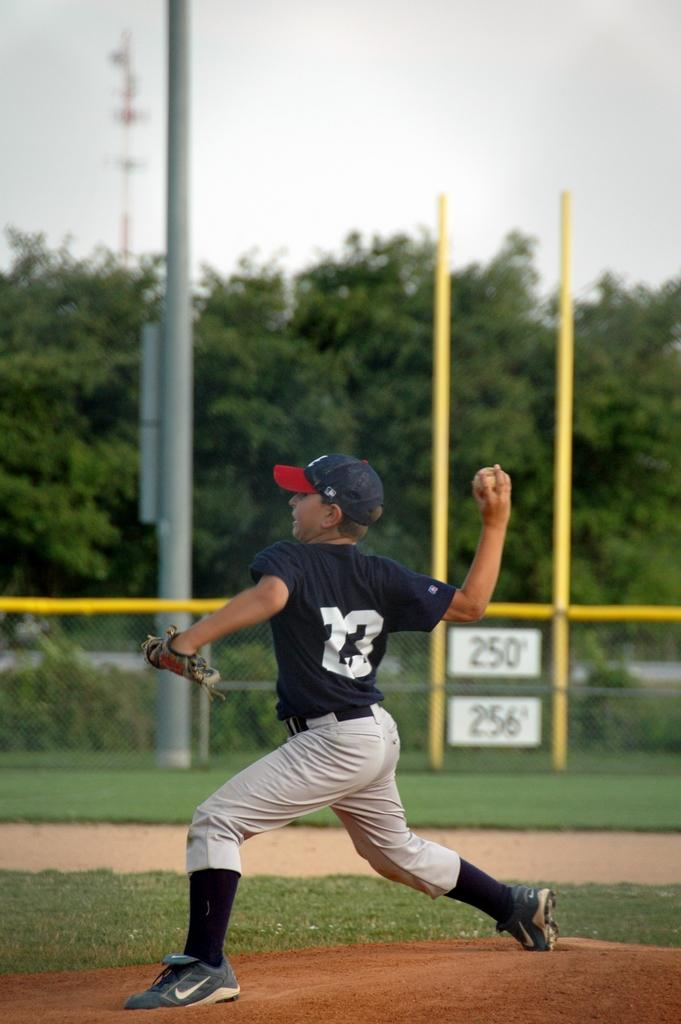<image>
Describe the image concisely. A boy throwing a baseball, with a sign in the background that has the numbers 256 